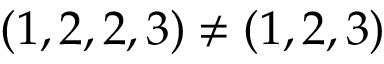Convert formula to latex. <formula><loc_0><loc_0><loc_500><loc_500>( 1 , 2 , 2 , 3 ) \neq ( 1 , 2 , 3 )</formula> 